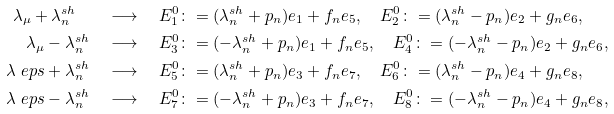Convert formula to latex. <formula><loc_0><loc_0><loc_500><loc_500>\lambda _ { \mu } + \lambda ^ { s h } _ { n } \quad & \longrightarrow \quad E _ { 1 } ^ { 0 } \colon = ( \lambda ^ { s h } _ { n } + p _ { n } ) e _ { 1 } + f _ { n } e _ { 5 } , \quad E _ { 2 } ^ { 0 } \colon = ( \lambda ^ { s h } _ { n } - p _ { n } ) e _ { 2 } + g _ { n } e _ { 6 } , \\ \lambda _ { \mu } - \lambda ^ { s h } _ { n } \quad & \longrightarrow \quad E _ { 3 } ^ { 0 } \colon = ( - \lambda ^ { s h } _ { n } + p _ { n } ) e _ { 1 } + f _ { n } e _ { 5 } , \quad E _ { 4 } ^ { 0 } \colon = ( - \lambda ^ { s h } _ { n } - p _ { n } ) e _ { 2 } + g _ { n } e _ { 6 } , \\ \lambda _ { \ } e p s + \lambda ^ { s h } _ { n } \quad & \longrightarrow \quad E _ { 5 } ^ { 0 } \colon = ( \lambda ^ { s h } _ { n } + p _ { n } ) e _ { 3 } + f _ { n } e _ { 7 } , \quad E _ { 6 } ^ { 0 } \colon = ( \lambda ^ { s h } _ { n } - p _ { n } ) e _ { 4 } + g _ { n } e _ { 8 } , \\ \lambda _ { \ } e p s - \lambda ^ { s h } _ { n } \quad & \longrightarrow \quad E _ { 7 } ^ { 0 } \colon = ( - \lambda ^ { s h } _ { n } + p _ { n } ) e _ { 3 } + f _ { n } e _ { 7 } , \quad E _ { 8 } ^ { 0 } \colon = ( - \lambda ^ { s h } _ { n } - p _ { n } ) e _ { 4 } + g _ { n } e _ { 8 } ,</formula> 